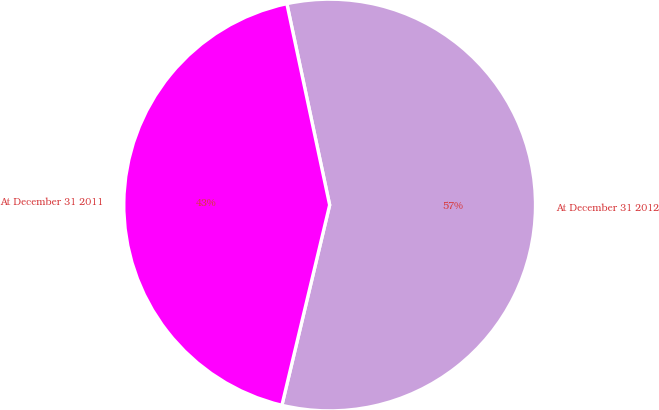<chart> <loc_0><loc_0><loc_500><loc_500><pie_chart><fcel>At December 31 2012<fcel>At December 31 2011<nl><fcel>57.06%<fcel>42.94%<nl></chart> 